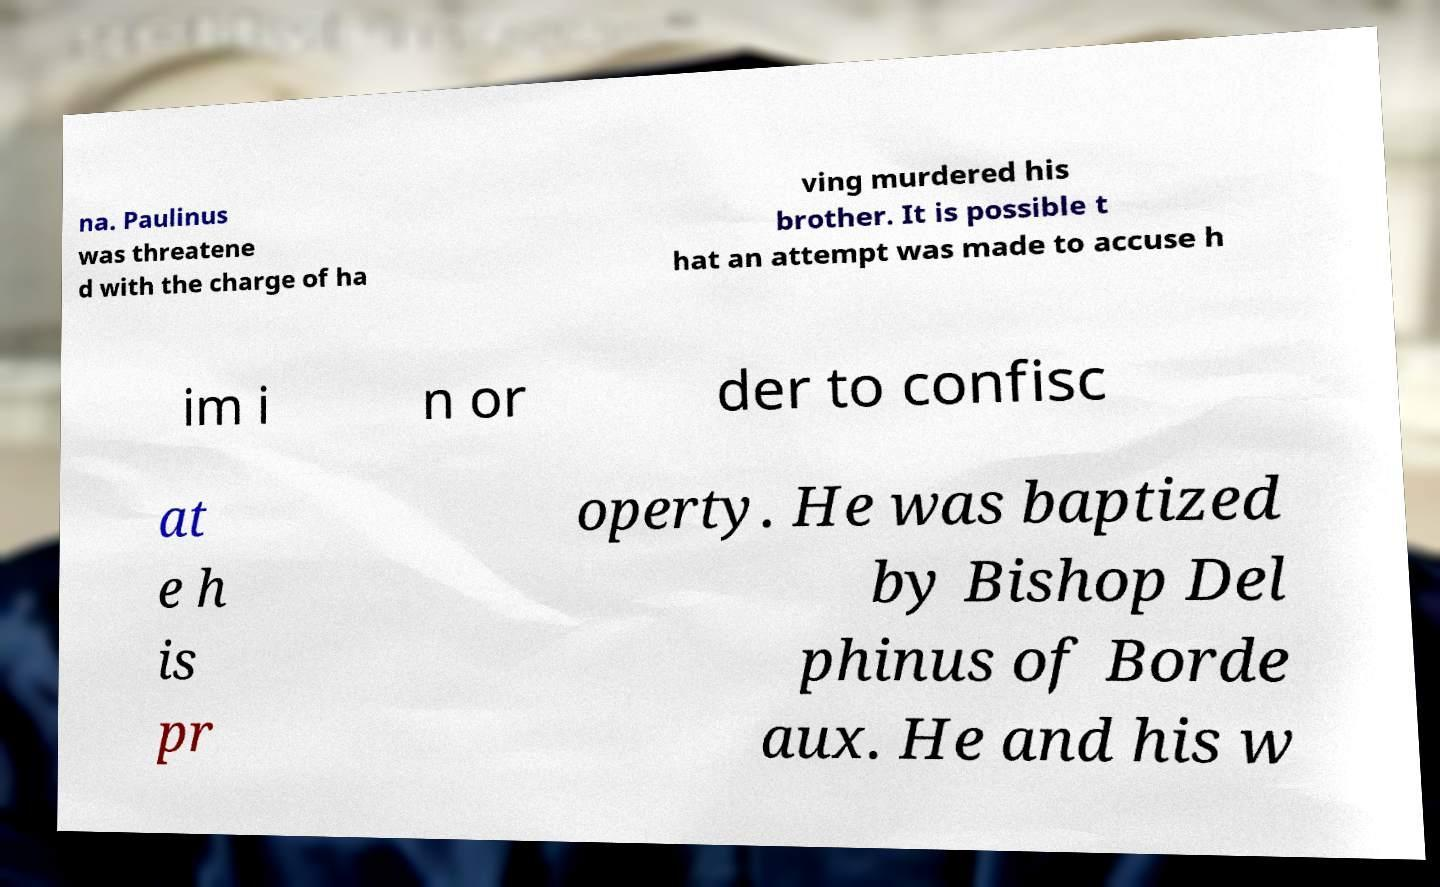Could you assist in decoding the text presented in this image and type it out clearly? na. Paulinus was threatene d with the charge of ha ving murdered his brother. It is possible t hat an attempt was made to accuse h im i n or der to confisc at e h is pr operty. He was baptized by Bishop Del phinus of Borde aux. He and his w 